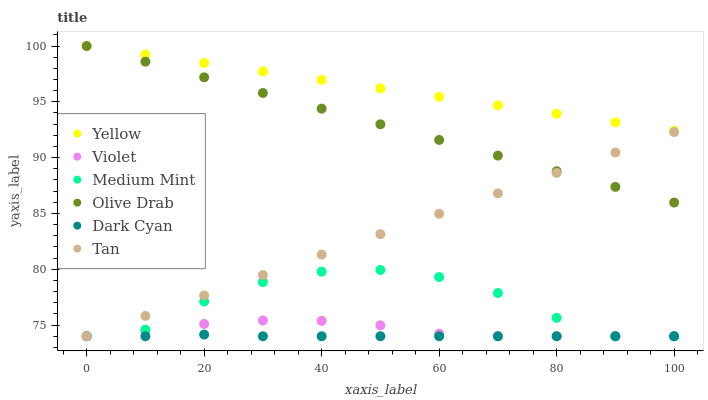Does Dark Cyan have the minimum area under the curve?
Answer yes or no. Yes. Does Yellow have the maximum area under the curve?
Answer yes or no. Yes. Does Violet have the minimum area under the curve?
Answer yes or no. No. Does Violet have the maximum area under the curve?
Answer yes or no. No. Is Yellow the smoothest?
Answer yes or no. Yes. Is Medium Mint the roughest?
Answer yes or no. Yes. Is Violet the smoothest?
Answer yes or no. No. Is Violet the roughest?
Answer yes or no. No. Does Medium Mint have the lowest value?
Answer yes or no. Yes. Does Yellow have the lowest value?
Answer yes or no. No. Does Olive Drab have the highest value?
Answer yes or no. Yes. Does Violet have the highest value?
Answer yes or no. No. Is Medium Mint less than Olive Drab?
Answer yes or no. Yes. Is Olive Drab greater than Medium Mint?
Answer yes or no. Yes. Does Yellow intersect Olive Drab?
Answer yes or no. Yes. Is Yellow less than Olive Drab?
Answer yes or no. No. Is Yellow greater than Olive Drab?
Answer yes or no. No. Does Medium Mint intersect Olive Drab?
Answer yes or no. No. 